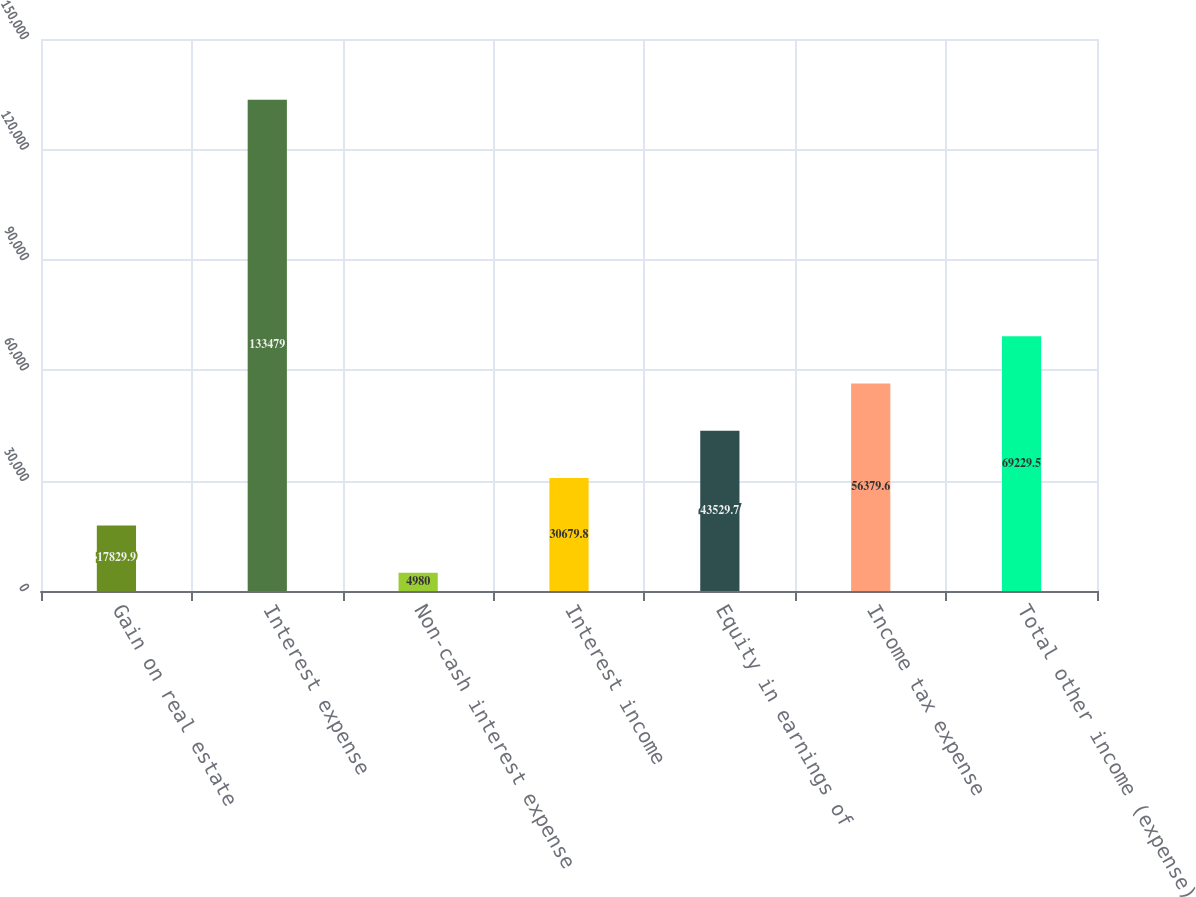Convert chart. <chart><loc_0><loc_0><loc_500><loc_500><bar_chart><fcel>Gain on real estate<fcel>Interest expense<fcel>Non-cash interest expense<fcel>Interest income<fcel>Equity in earnings of<fcel>Income tax expense<fcel>Total other income (expense)<nl><fcel>17829.9<fcel>133479<fcel>4980<fcel>30679.8<fcel>43529.7<fcel>56379.6<fcel>69229.5<nl></chart> 